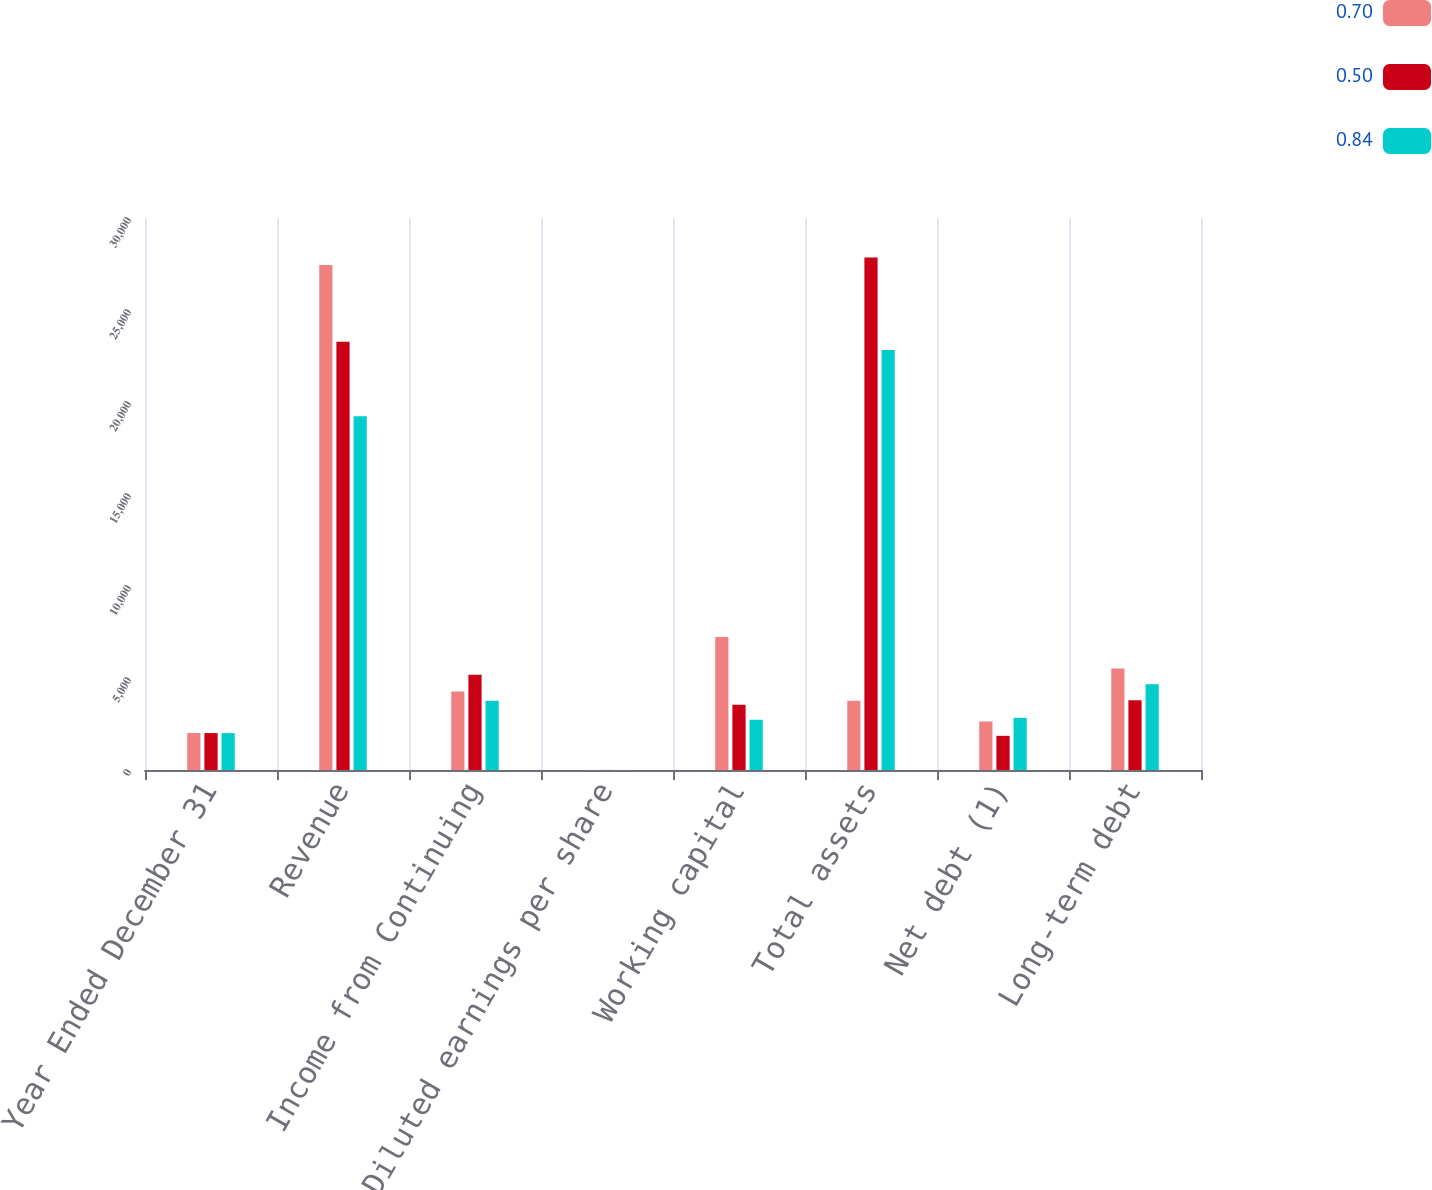Convert chart. <chart><loc_0><loc_0><loc_500><loc_500><stacked_bar_chart><ecel><fcel>Year Ended December 31<fcel>Revenue<fcel>Income from Continuing<fcel>Diluted earnings per share<fcel>Working capital<fcel>Total assets<fcel>Net debt (1)<fcel>Long-term debt<nl><fcel>0.7<fcel>2010<fcel>27447<fcel>4266<fcel>3.38<fcel>7233<fcel>3759<fcel>2638<fcel>5517<nl><fcel>0.5<fcel>2007<fcel>23277<fcel>5177<fcel>4.2<fcel>3551<fcel>27853<fcel>1857<fcel>3794<nl><fcel>0.84<fcel>2006<fcel>19230<fcel>3759<fcel>3.01<fcel>2731<fcel>22832<fcel>2834<fcel>4664<nl></chart> 